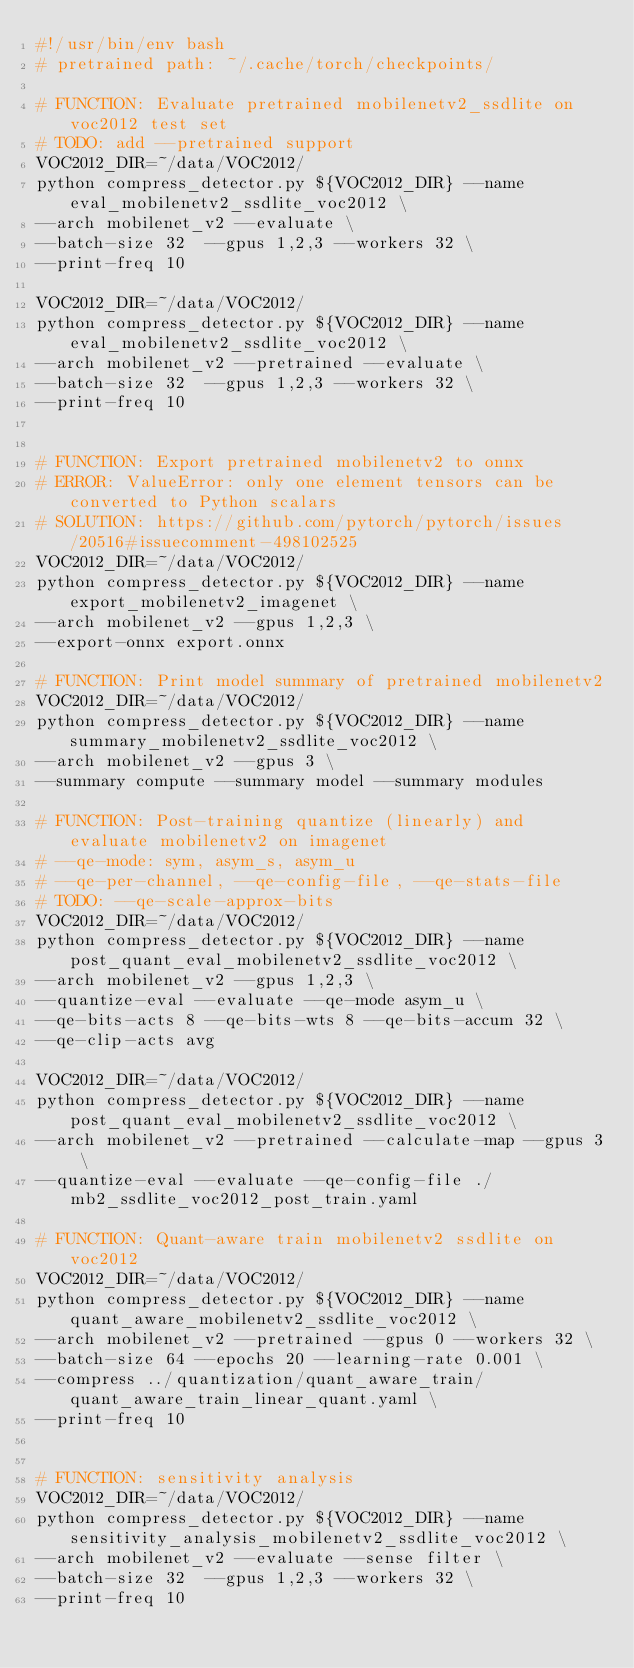<code> <loc_0><loc_0><loc_500><loc_500><_Bash_>#!/usr/bin/env bash
# pretrained path: ~/.cache/torch/checkpoints/

# FUNCTION: Evaluate pretrained mobilenetv2_ssdlite on voc2012 test set
# TODO: add --pretrained support
VOC2012_DIR=~/data/VOC2012/
python compress_detector.py ${VOC2012_DIR} --name eval_mobilenetv2_ssdlite_voc2012 \
--arch mobilenet_v2 --evaluate \
--batch-size 32  --gpus 1,2,3 --workers 32 \
--print-freq 10

VOC2012_DIR=~/data/VOC2012/
python compress_detector.py ${VOC2012_DIR} --name eval_mobilenetv2_ssdlite_voc2012 \
--arch mobilenet_v2 --pretrained --evaluate \
--batch-size 32  --gpus 1,2,3 --workers 32 \
--print-freq 10


# FUNCTION: Export pretrained mobilenetv2 to onnx
# ERROR: ValueError: only one element tensors can be converted to Python scalars
# SOLUTION: https://github.com/pytorch/pytorch/issues/20516#issuecomment-498102525
VOC2012_DIR=~/data/VOC2012/
python compress_detector.py ${VOC2012_DIR} --name export_mobilenetv2_imagenet \
--arch mobilenet_v2 --gpus 1,2,3 \
--export-onnx export.onnx

# FUNCTION: Print model summary of pretrained mobilenetv2
VOC2012_DIR=~/data/VOC2012/
python compress_detector.py ${VOC2012_DIR} --name summary_mobilenetv2_ssdlite_voc2012 \
--arch mobilenet_v2 --gpus 3 \
--summary compute --summary model --summary modules

# FUNCTION: Post-training quantize (linearly) and evaluate mobilenetv2 on imagenet
# --qe-mode: sym, asym_s, asym_u
# --qe-per-channel, --qe-config-file, --qe-stats-file
# TODO: --qe-scale-approx-bits
VOC2012_DIR=~/data/VOC2012/
python compress_detector.py ${VOC2012_DIR} --name post_quant_eval_mobilenetv2_ssdlite_voc2012 \
--arch mobilenet_v2 --gpus 1,2,3 \
--quantize-eval --evaluate --qe-mode asym_u \
--qe-bits-acts 8 --qe-bits-wts 8 --qe-bits-accum 32 \
--qe-clip-acts avg

VOC2012_DIR=~/data/VOC2012/
python compress_detector.py ${VOC2012_DIR} --name post_quant_eval_mobilenetv2_ssdlite_voc2012 \
--arch mobilenet_v2 --pretrained --calculate-map --gpus 3 \
--quantize-eval --evaluate --qe-config-file ./mb2_ssdlite_voc2012_post_train.yaml

# FUNCTION: Quant-aware train mobilenetv2 ssdlite on voc2012
VOC2012_DIR=~/data/VOC2012/
python compress_detector.py ${VOC2012_DIR} --name quant_aware_mobilenetv2_ssdlite_voc2012 \
--arch mobilenet_v2 --pretrained --gpus 0 --workers 32 \
--batch-size 64 --epochs 20 --learning-rate 0.001 \
--compress ../quantization/quant_aware_train/quant_aware_train_linear_quant.yaml \
--print-freq 10


# FUNCTION: sensitivity analysis
VOC2012_DIR=~/data/VOC2012/
python compress_detector.py ${VOC2012_DIR} --name sensitivity_analysis_mobilenetv2_ssdlite_voc2012 \
--arch mobilenet_v2 --evaluate --sense filter \
--batch-size 32  --gpus 1,2,3 --workers 32 \
--print-freq 10</code> 